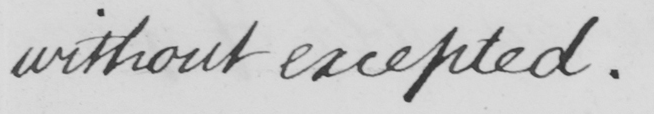Please provide the text content of this handwritten line. without excepted . 